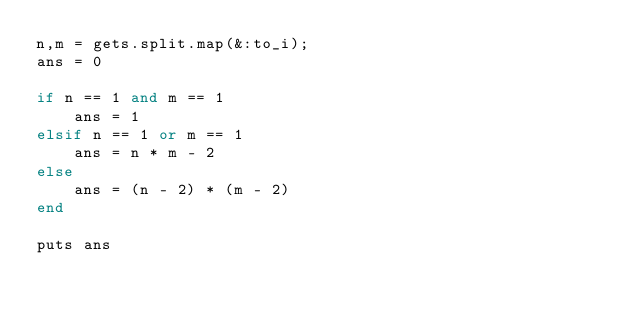Convert code to text. <code><loc_0><loc_0><loc_500><loc_500><_Ruby_>n,m = gets.split.map(&:to_i);
ans = 0

if n == 1 and m == 1
    ans = 1
elsif n == 1 or m == 1
    ans = n * m - 2
else 
    ans = (n - 2) * (m - 2) 
end

puts ans
</code> 